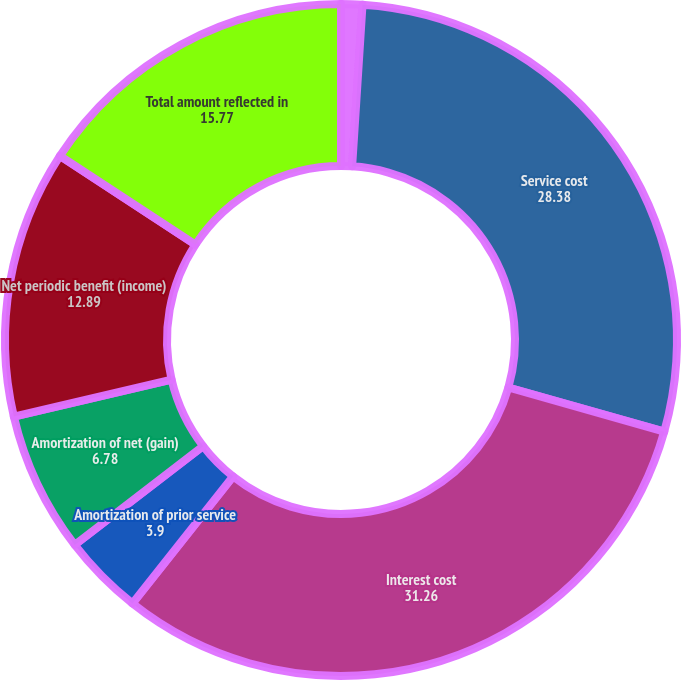<chart> <loc_0><loc_0><loc_500><loc_500><pie_chart><fcel>For the years ended December<fcel>Service cost<fcel>Interest cost<fcel>Amortization of prior service<fcel>Amortization of net (gain)<fcel>Net periodic benefit (income)<fcel>Total amount reflected in<nl><fcel>1.02%<fcel>28.38%<fcel>31.26%<fcel>3.9%<fcel>6.78%<fcel>12.89%<fcel>15.77%<nl></chart> 